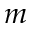<formula> <loc_0><loc_0><loc_500><loc_500>m</formula> 